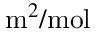Convert formula to latex. <formula><loc_0><loc_0><loc_500><loc_500>m ^ { 2 } / m o l</formula> 